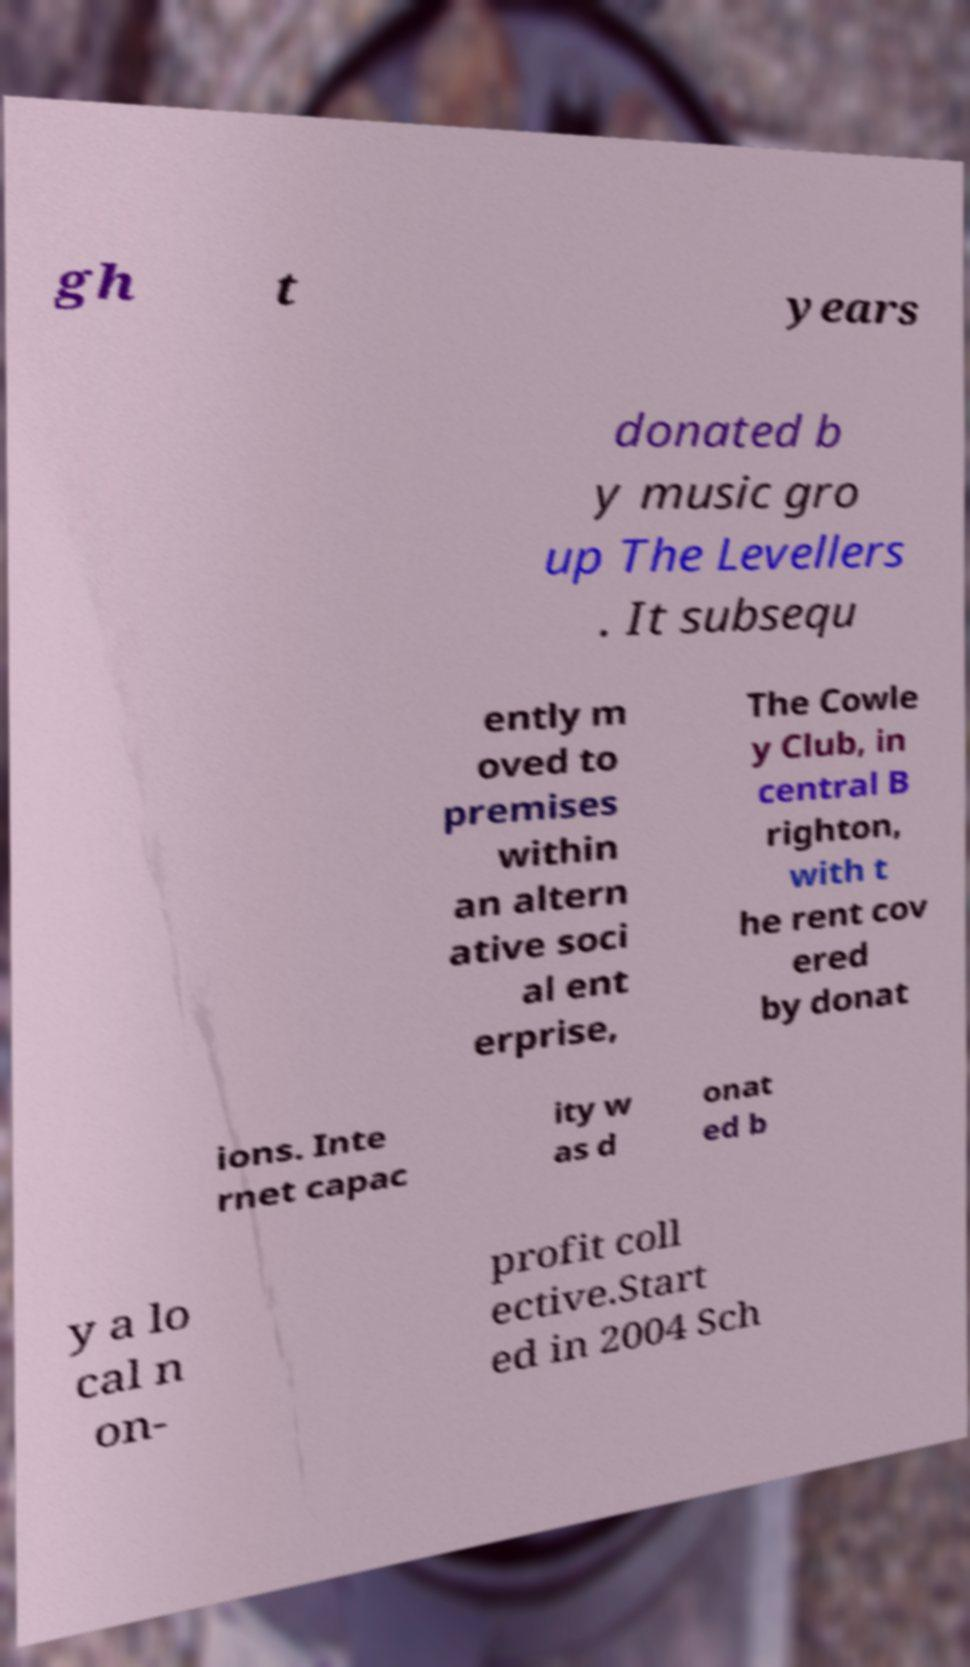Could you extract and type out the text from this image? gh t years donated b y music gro up The Levellers . It subsequ ently m oved to premises within an altern ative soci al ent erprise, The Cowle y Club, in central B righton, with t he rent cov ered by donat ions. Inte rnet capac ity w as d onat ed b y a lo cal n on- profit coll ective.Start ed in 2004 Sch 